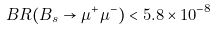<formula> <loc_0><loc_0><loc_500><loc_500>B R ( B _ { s } \to \mu ^ { + } \mu ^ { - } ) < 5 . 8 \times 1 0 ^ { - 8 }</formula> 